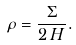<formula> <loc_0><loc_0><loc_500><loc_500>\rho = \frac { \Sigma } { 2 \, H } .</formula> 